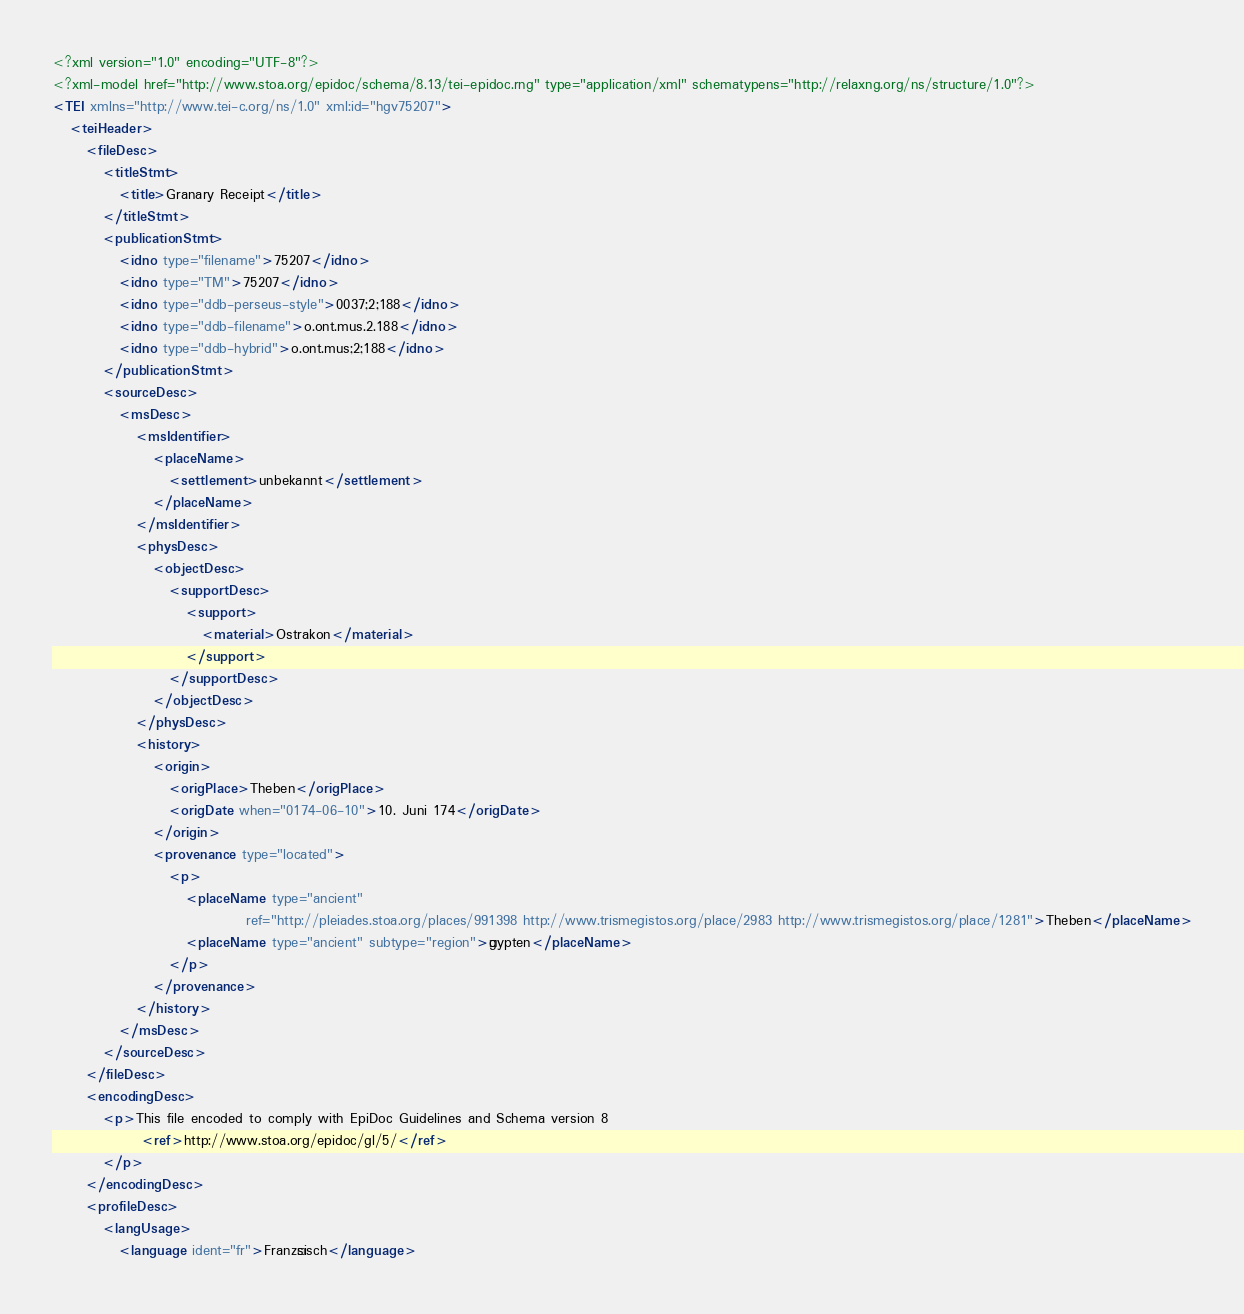Convert code to text. <code><loc_0><loc_0><loc_500><loc_500><_XML_><?xml version="1.0" encoding="UTF-8"?>
<?xml-model href="http://www.stoa.org/epidoc/schema/8.13/tei-epidoc.rng" type="application/xml" schematypens="http://relaxng.org/ns/structure/1.0"?>
<TEI xmlns="http://www.tei-c.org/ns/1.0" xml:id="hgv75207">
   <teiHeader>
      <fileDesc>
         <titleStmt>
            <title>Granary Receipt</title>
         </titleStmt>
         <publicationStmt>
            <idno type="filename">75207</idno>
            <idno type="TM">75207</idno>
            <idno type="ddb-perseus-style">0037;2;188</idno>
            <idno type="ddb-filename">o.ont.mus.2.188</idno>
            <idno type="ddb-hybrid">o.ont.mus;2;188</idno>
         </publicationStmt>
         <sourceDesc>
            <msDesc>
               <msIdentifier>
                  <placeName>
                     <settlement>unbekannt</settlement>
                  </placeName>
               </msIdentifier>
               <physDesc>
                  <objectDesc>
                     <supportDesc>
                        <support>
                           <material>Ostrakon</material>
                        </support>
                     </supportDesc>
                  </objectDesc>
               </physDesc>
               <history>
                  <origin>
                     <origPlace>Theben</origPlace>
                     <origDate when="0174-06-10">10. Juni 174</origDate>
                  </origin>
                  <provenance type="located">
                     <p>
                        <placeName type="ancient"
                                   ref="http://pleiades.stoa.org/places/991398 http://www.trismegistos.org/place/2983 http://www.trismegistos.org/place/1281">Theben</placeName>
                        <placeName type="ancient" subtype="region">Ägypten</placeName>
                     </p>
                  </provenance>
               </history>
            </msDesc>
         </sourceDesc>
      </fileDesc>
      <encodingDesc>
         <p>This file encoded to comply with EpiDoc Guidelines and Schema version 8
                <ref>http://www.stoa.org/epidoc/gl/5/</ref>
         </p>
      </encodingDesc>
      <profileDesc>
         <langUsage>
            <language ident="fr">Französisch</language></code> 